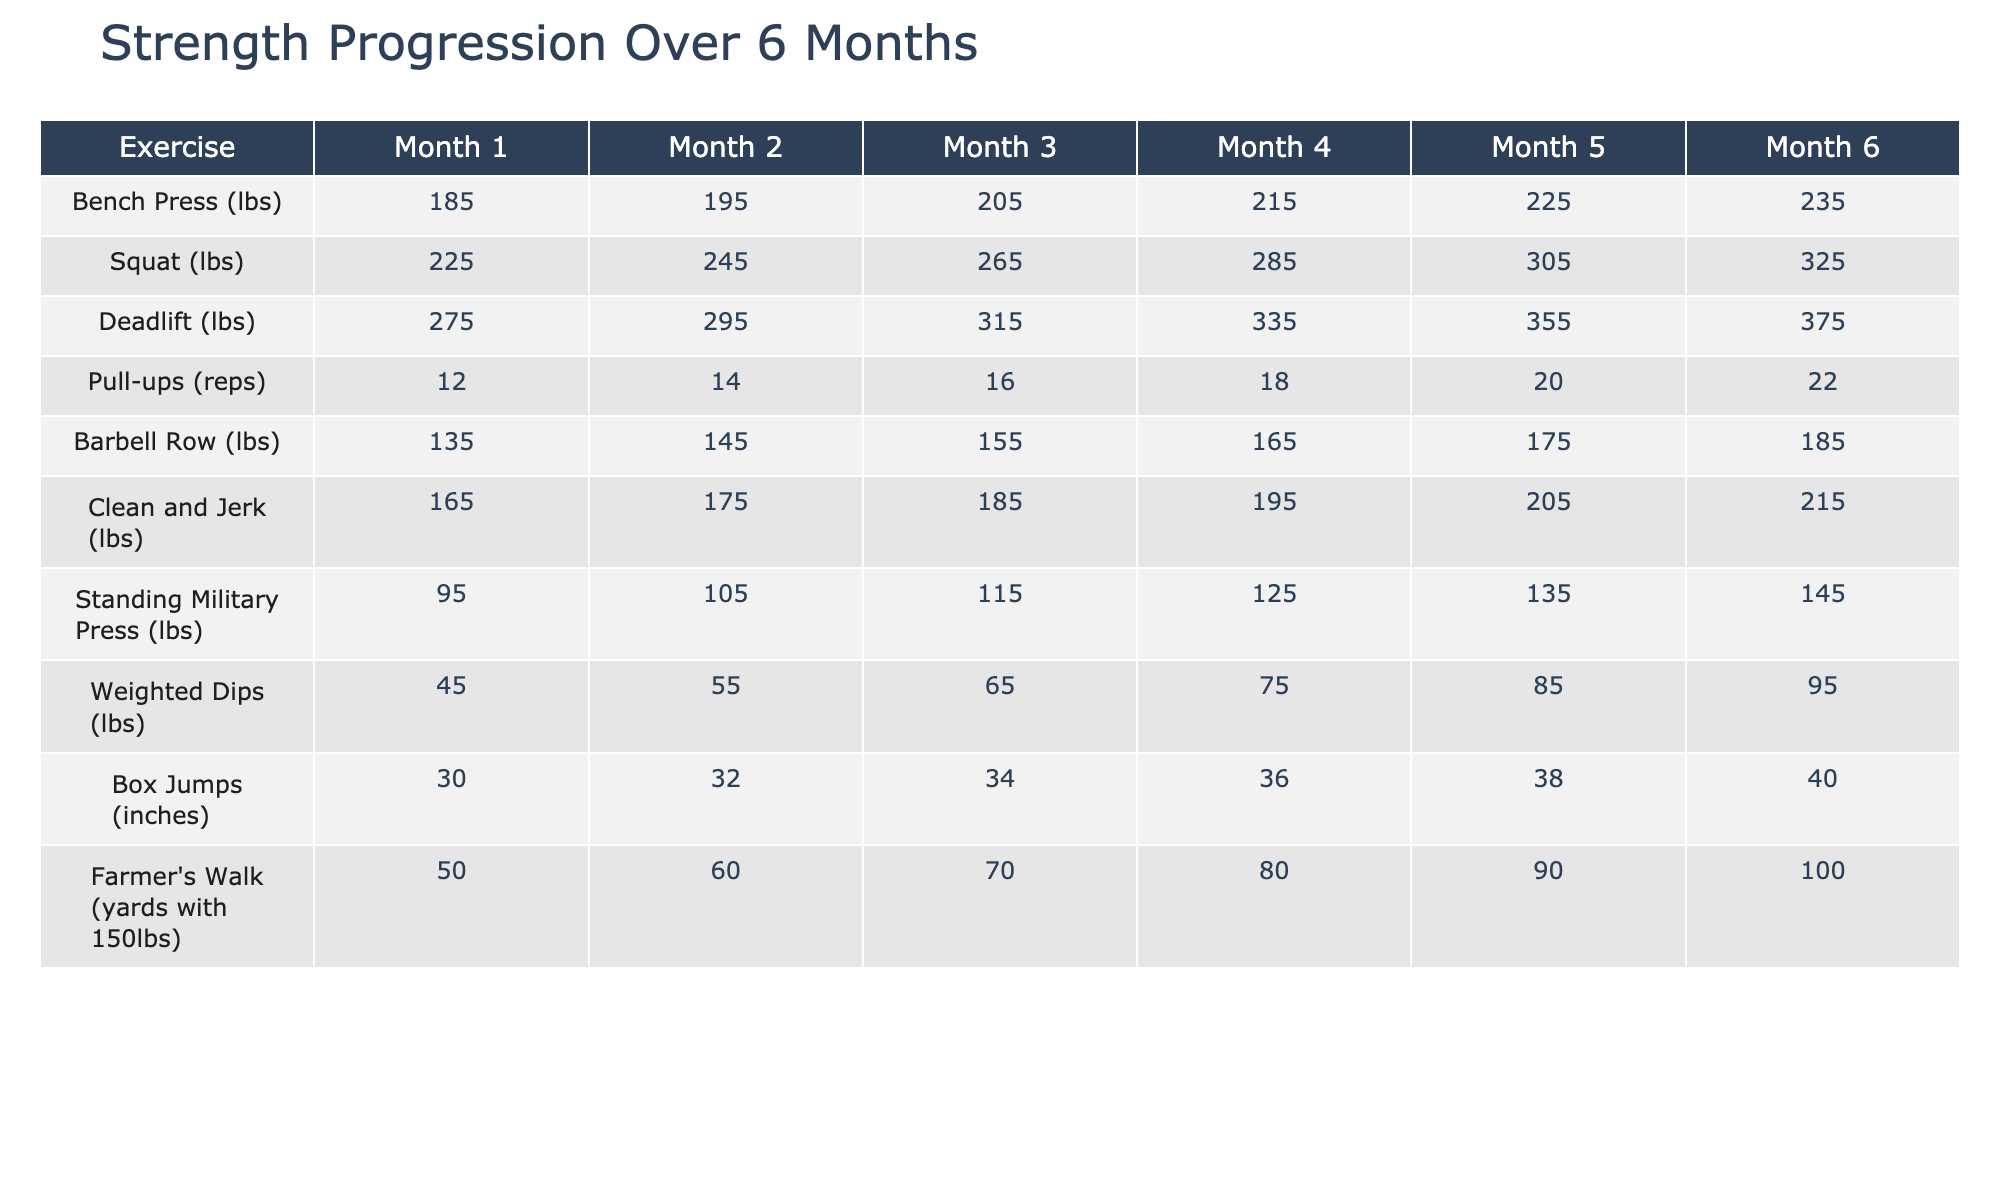What is the maximum weight lifted in the Deadlift at Month 6? According to the table, the weight lifted in the Deadlift at Month 6 is 375 lbs.
Answer: 375 lbs What was the increase in Weight Dips from Month 1 to Month 6? The weight in Month 1 is 45 lbs and in Month 6 is 95 lbs. The increase is calculated as 95 - 45 = 50 lbs.
Answer: 50 lbs Did the Squat weight ever decrease during the 6-month period? By examining the Squat data from Month 1 to Month 6, there are no decreases; the weights consistently increased.
Answer: No What is the average weight lifted in the Bench Press over the 6 months? The Bench Press weights are 185, 195, 205, 215, 225, and 235 lbs. The total is 1,260 lbs. Dividing by 6 gives an average of 210 lbs.
Answer: 210 lbs In which month did the most significant weight increase occur in the Clean and Jerk? The Clean and Jerk weight increased from 205 lbs in Month 5 to 215 lbs in Month 6, which is the first 10 lb increase after consistent increases of 10 lbs for previous months. However, the largest monthly increase was from Month 4 to Month 5 (195 to 205 lbs = 10 lbs).
Answer: Month 5 (10 lbs) What is the total number of Pull-ups performed in Month 3? The table shows 16 reps for Pull-ups in Month 3.
Answer: 16 reps What percentage increase in weight was achieved in the Squat from Month 1 to Month 6? Squat in Month 1 is 225 lbs and in Month 6 is 325 lbs. The increase is 325 - 225 = 100 lbs. The percentage increase is (100 / 225) * 100 ≈ 44.44%.
Answer: Approximately 44.44% Which exercise had the highest starting weight in Month 1? In Month 1, Deadlift starts at 275 lbs, which is higher than the other exercises.
Answer: Deadlift Across all exercises listed, which one had the lowest weight in Month 4? In Month 4, the Standing Military Press had the lowest weight at 125 lbs compared to other exercises that all had higher values.
Answer: Standing Military Press Which exercise shows a consistent increase of 10 lbs every month? The Clean and Jerk maintains a 10 lbs increase each month from Month 1 to Month 6, indicating a steady progression in this exercise.
Answer: Clean and Jerk What was the total distance covered in the Farmer's Walk at Month 5? The distance recorded for the Farmer's Walk in Month 5 is 90 yards.
Answer: 90 yards 